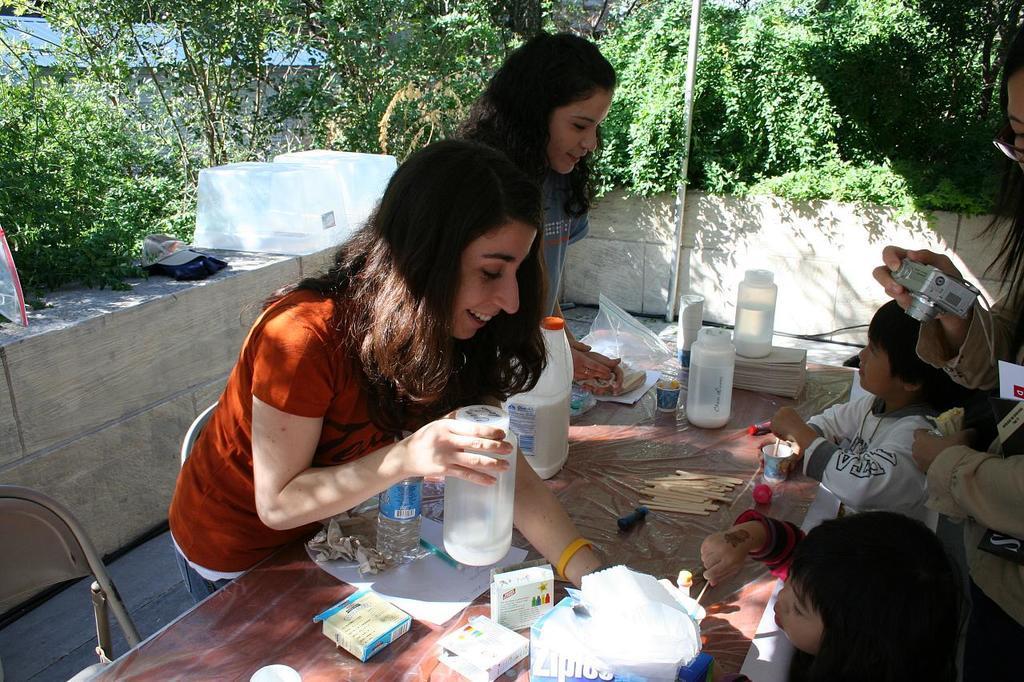In one or two sentences, can you explain what this image depicts? There are two girls standing in front of a table. Two children sitting in front of a table in the chairs. One girl is taking a pictures with camera. On the table there are some food items. In the background there is a pole and some trees here. 